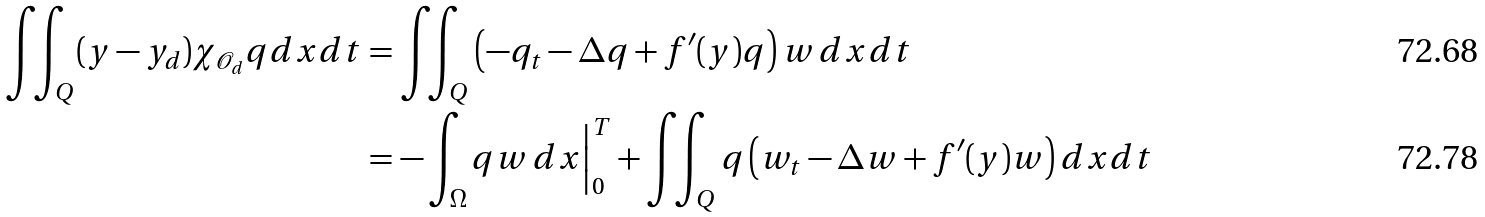<formula> <loc_0><loc_0><loc_500><loc_500>\iint _ { Q } ( y - y _ { d } ) \chi _ { \mathcal { O } _ { d } } q d x d t & = \iint _ { Q } \left ( - q _ { t } - \Delta q + f ^ { \prime } ( y ) q \right ) w \, d x d t \\ & = - \int _ { \Omega } q w \, d x \Big | _ { 0 } ^ { T } + \iint _ { Q } q \left ( w _ { t } - \Delta w + f ^ { \prime } ( y ) w \right ) d x d t</formula> 